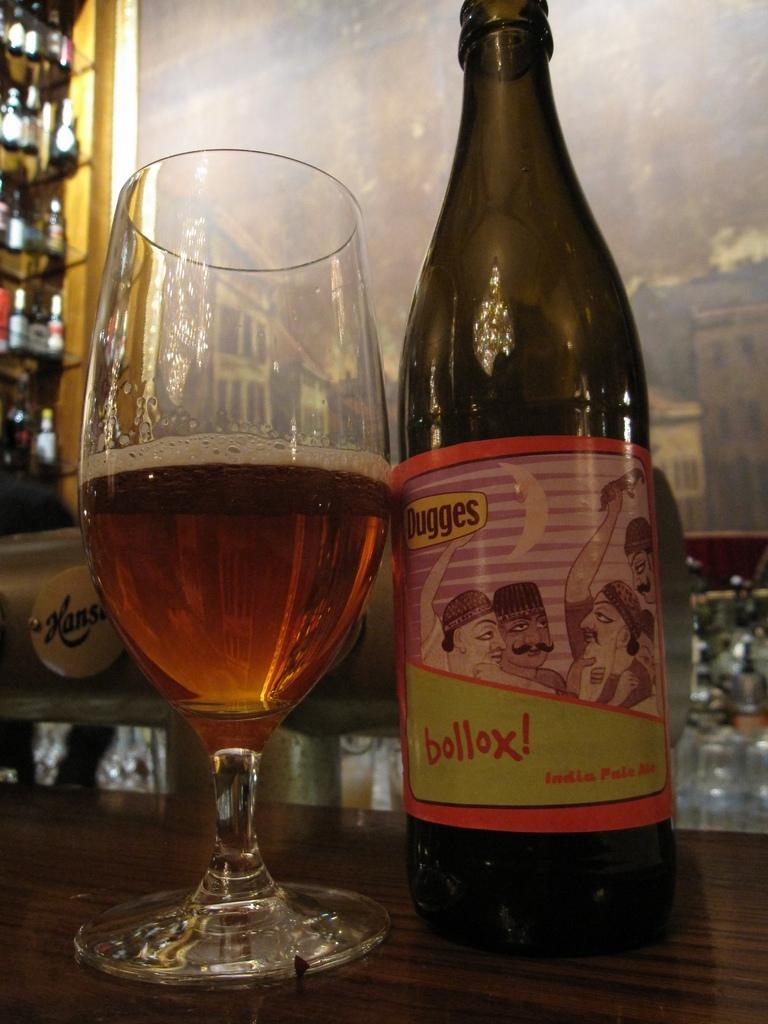What type of container is visible in the image? There is a glass in the image. What other type of container can be seen in the image? There is a bottle in the image. Can you describe the background of the image? The background of the image includes many bottles. What type of calendar is hanging on the wall in the image? There is no calendar present in the image. What type of smell can be detected from the image? There is no information about any smell in the image. 